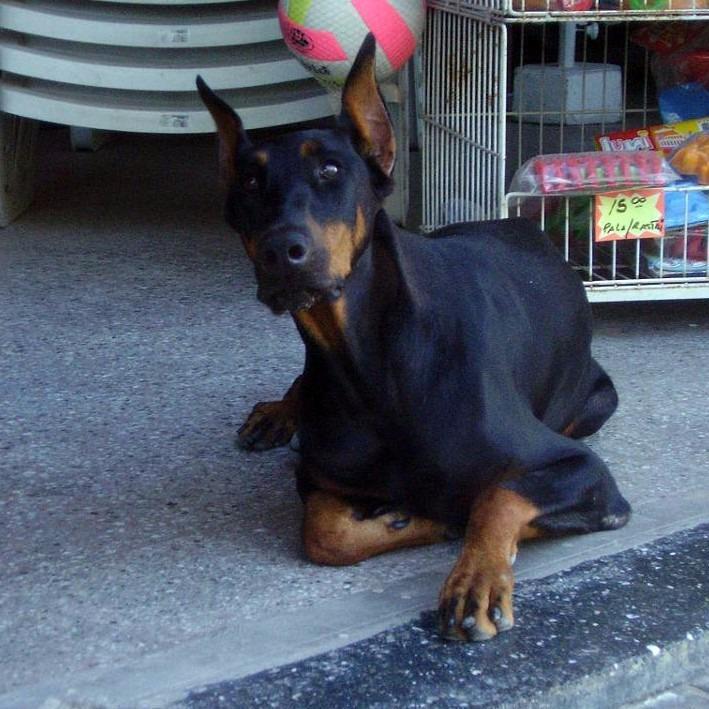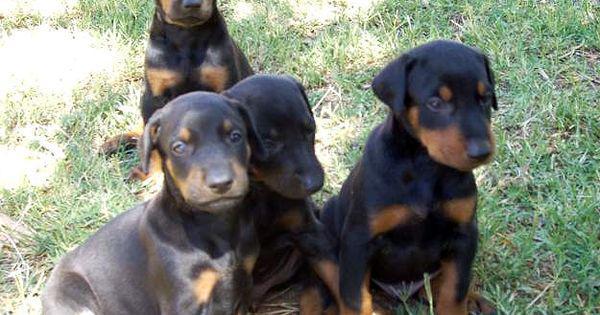The first image is the image on the left, the second image is the image on the right. Evaluate the accuracy of this statement regarding the images: "The left and right image contains the same number of dogs.". Is it true? Answer yes or no. No. The first image is the image on the left, the second image is the image on the right. For the images shown, is this caption "There are more dogs in the image on the right." true? Answer yes or no. Yes. 